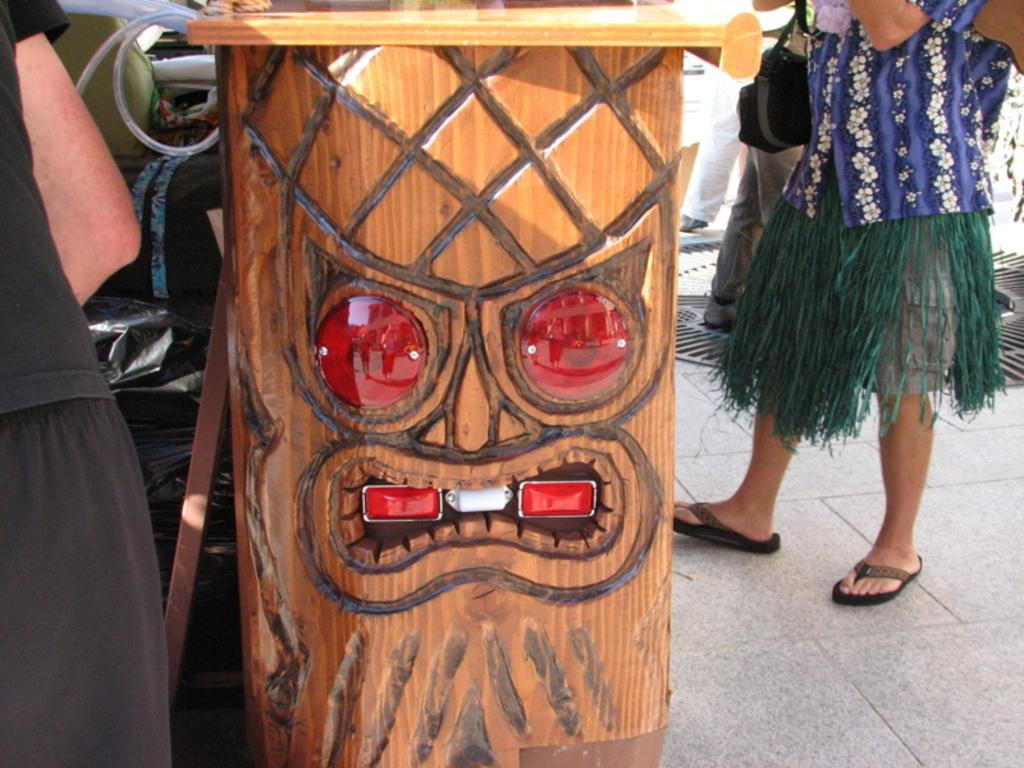What is the main object in the image? There is a wooden log in the image. What is attached to the wooden log? Lights are fixed on the wooden log. Can you describe the people in the image? There are people standing on a platform in the image. What activity is the wooden log participating in during the month of June? The wooden log is not capable of participating in activities, and the month of June is not mentioned in the image. 